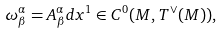<formula> <loc_0><loc_0><loc_500><loc_500>\omega ^ { \alpha } _ { \beta } = A ^ { \alpha } _ { \beta } d x ^ { 1 } \in C ^ { 0 } ( M , T ^ { \vee } ( M ) ) ,</formula> 